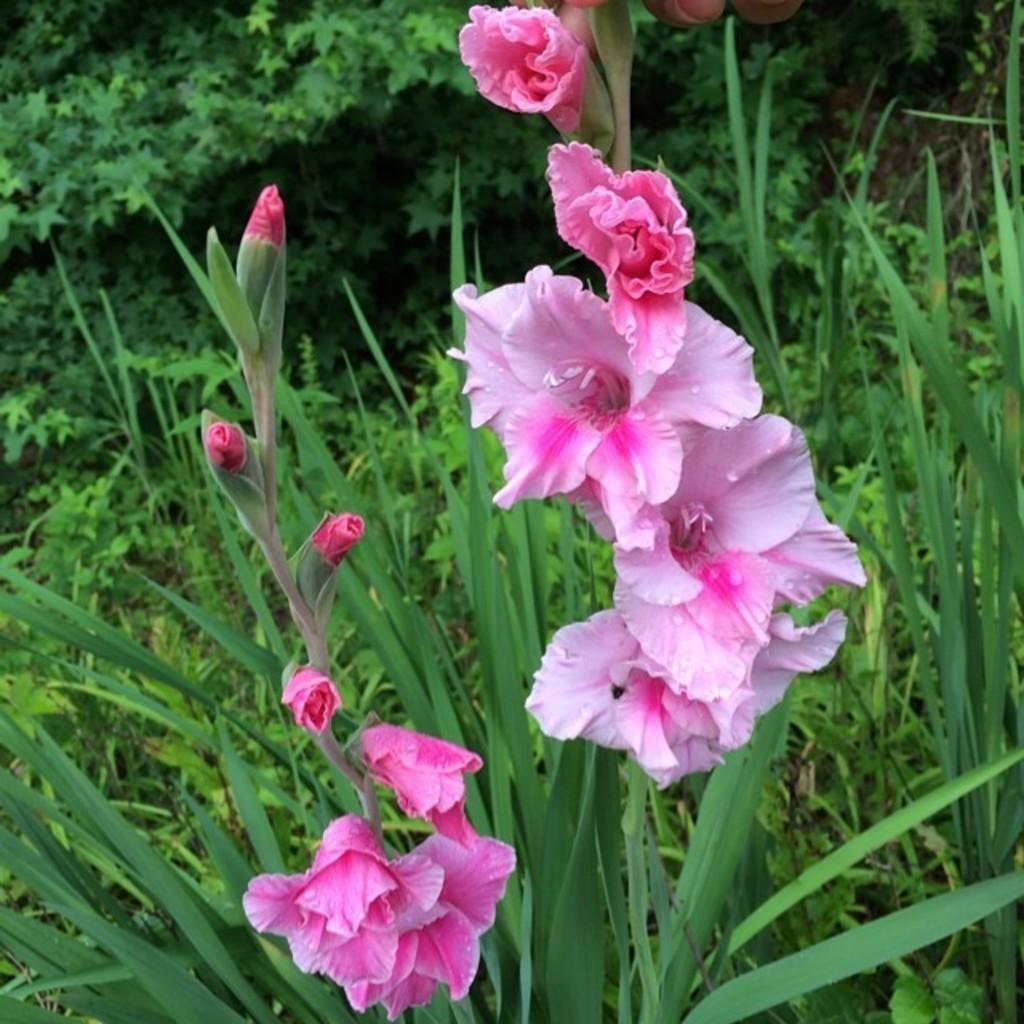How would you summarize this image in a sentence or two? In the middle of the image we can see some flowers. Behind the flowers there are some plants and trees. At the top of the image we can see some fingers. 